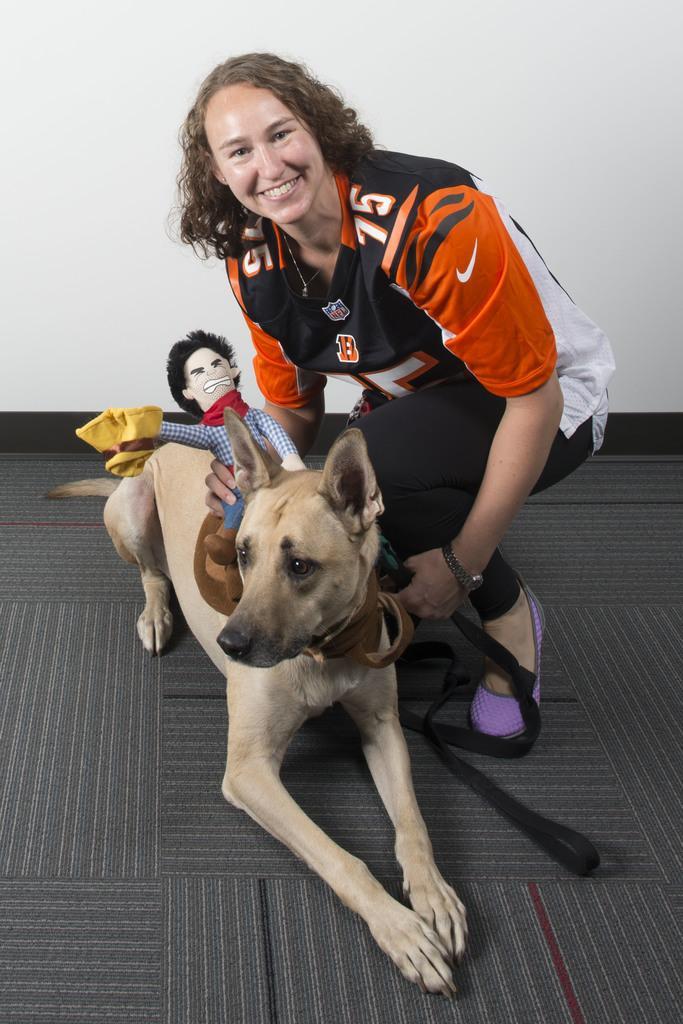Could you give a brief overview of what you see in this image? In this image I see a woman who is smiling and she is holding a soft toy and it is on the dog. In the background pic is the wall. 